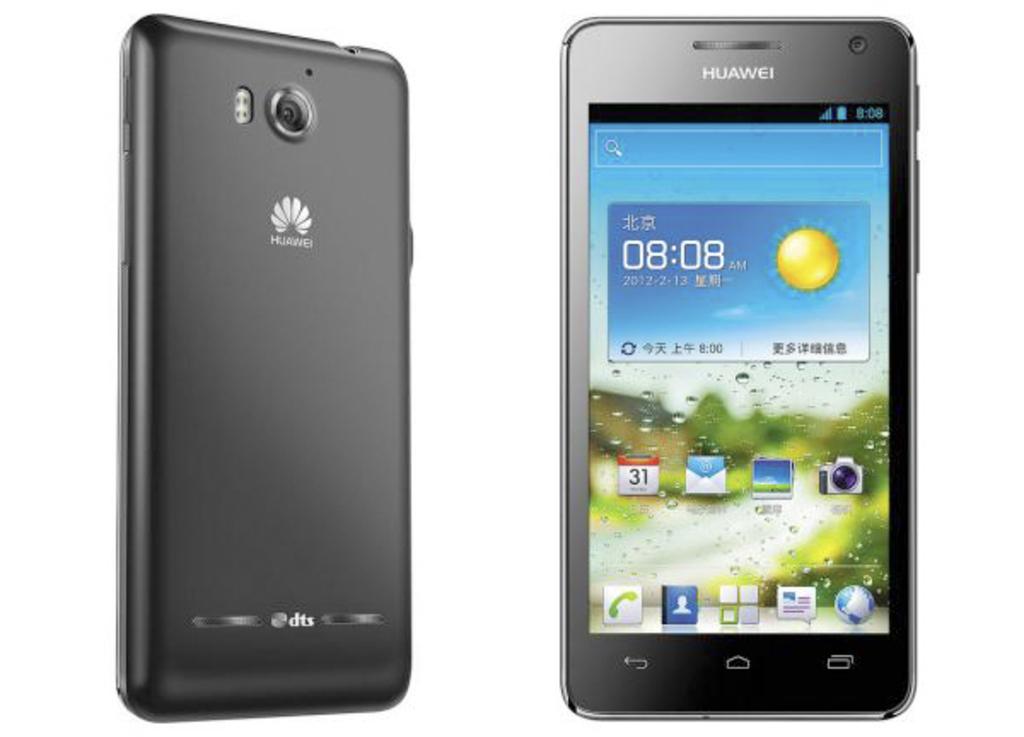What brand of phone is this?
Provide a short and direct response. Huawei. Is dts written on the bottom of the back of this phone?
Offer a very short reply. Yes. 